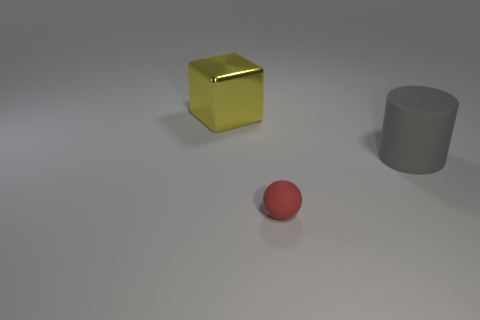Add 2 red things. How many objects exist? 5 Subtract all balls. How many objects are left? 2 Subtract all green spheres. Subtract all cyan cylinders. How many spheres are left? 1 Add 3 gray rubber objects. How many gray rubber objects are left? 4 Add 3 large purple cylinders. How many large purple cylinders exist? 3 Subtract 0 purple balls. How many objects are left? 3 Subtract all gray matte cylinders. Subtract all gray matte things. How many objects are left? 1 